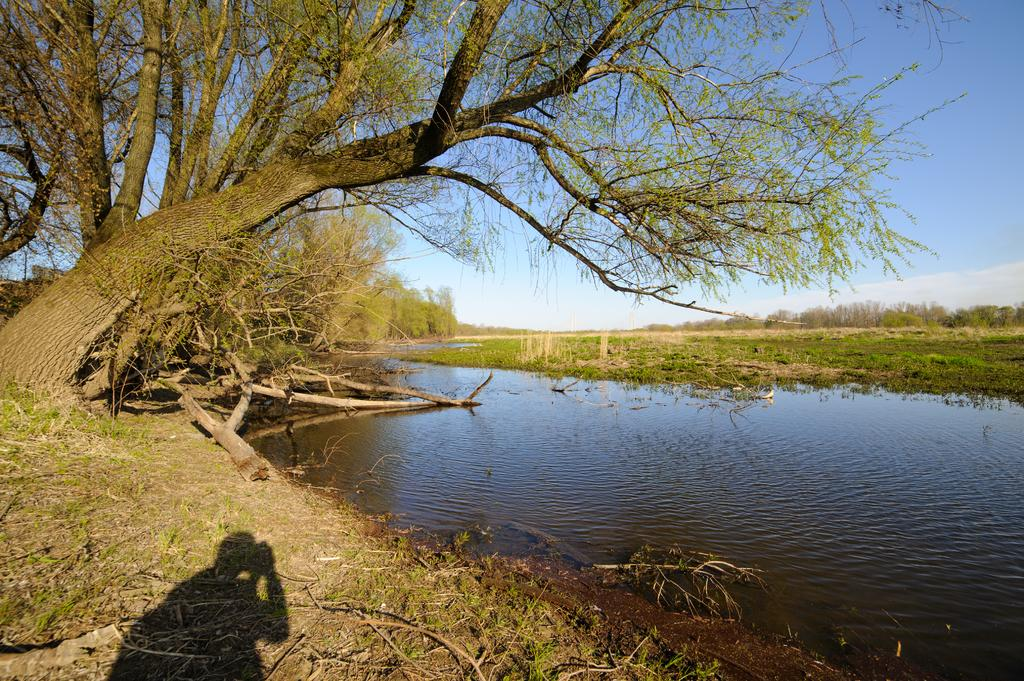What type of natural feature is present in the image? There is a lake in the image. Can you describe any human presence in the image? There is a shadow of a person on the left side of the image. What type of vegetation can be seen in the image? There are trees in the image. What is visible in the background of the image? The sky is visible in the background of the image. What type of feather can be seen on the stage in the image? There is no stage or feather present in the image. What type of insurance policy is being discussed in the image? There is no discussion of insurance in the image. 